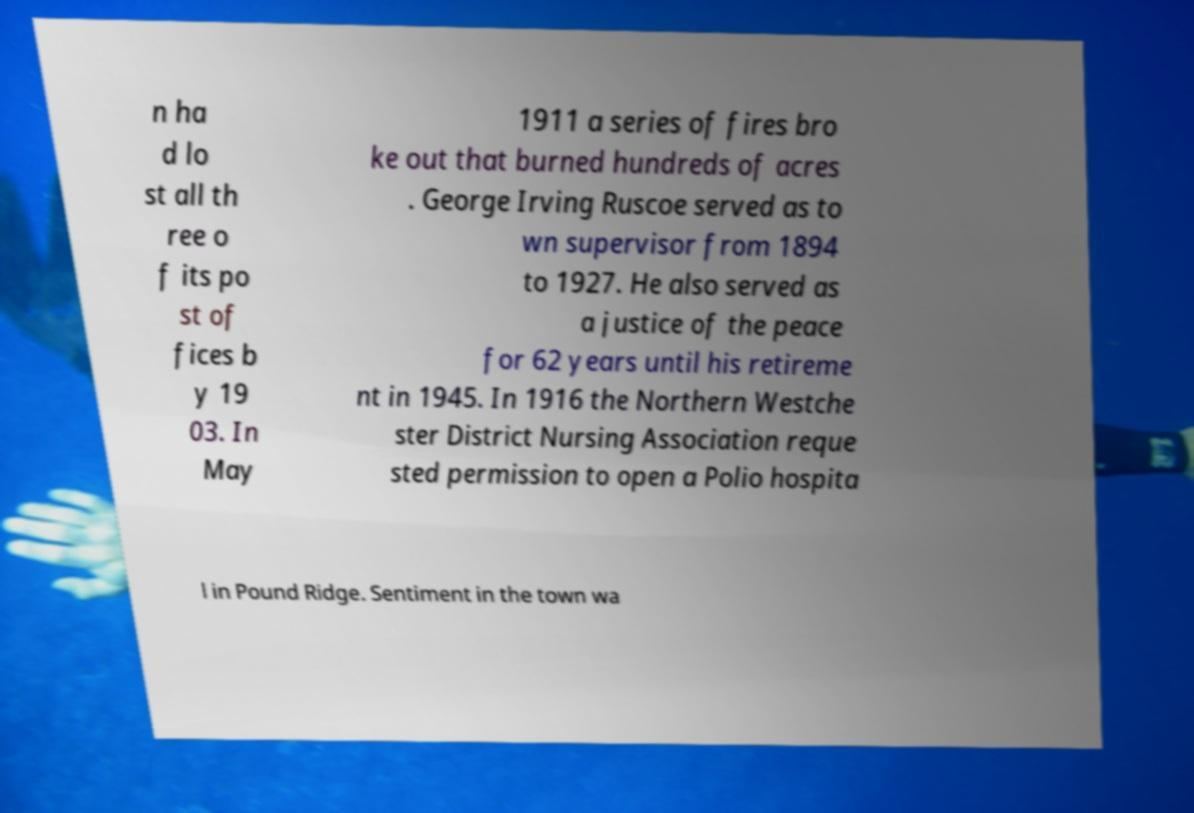For documentation purposes, I need the text within this image transcribed. Could you provide that? n ha d lo st all th ree o f its po st of fices b y 19 03. In May 1911 a series of fires bro ke out that burned hundreds of acres . George Irving Ruscoe served as to wn supervisor from 1894 to 1927. He also served as a justice of the peace for 62 years until his retireme nt in 1945. In 1916 the Northern Westche ster District Nursing Association reque sted permission to open a Polio hospita l in Pound Ridge. Sentiment in the town wa 